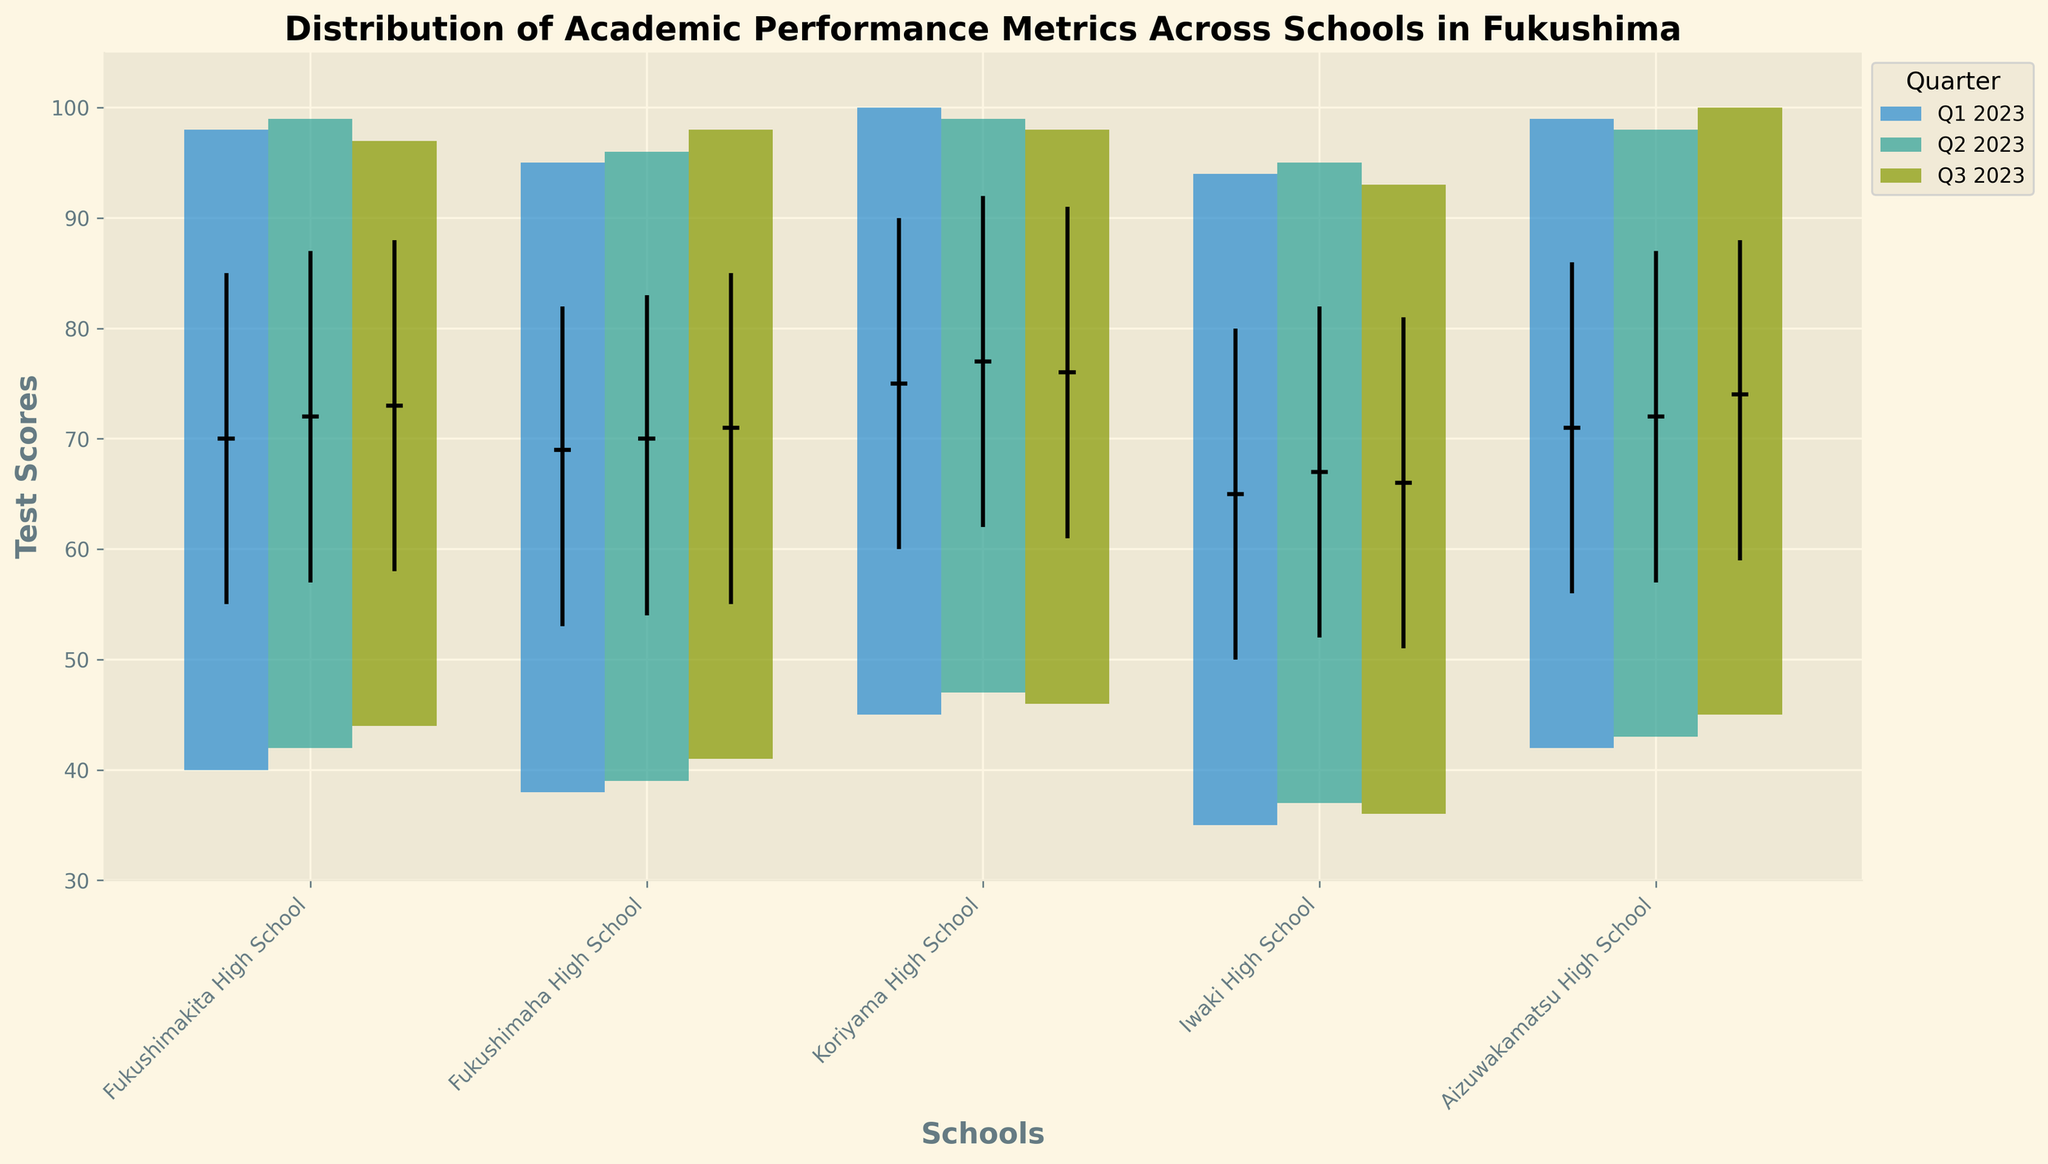What is the maximum test score in Koriyama High School for Q1 2023? First, find the bar corresponding to Koriyama High School for Q1 2023. The maximum test score in this quarter is marked by the top of the bar. According to the y-axis and the figure's labels, the maximum score for this school in Q1 2023 is 100.
Answer: 100 Which school had the lowest median score in Q1 2023, and what was that score? To find this, observe the black horizontal median lines for Q1 2023. The school with the lowest such line represents the lowest median score. For Q1 2023, Iwaki High School has the lowest median score at 65.
Answer: Iwaki High School, 65 How did Aizuwakamatsu High School's maximum score change from Q1 2023 to Q3 2023? Compare the topmost points of the bars for Aizuwakamatsu High School in Q1 and Q3 2023 to see the change. The score increased from 99 in Q1 2023 to 100 in Q3 2023, showing an increase of 1.
Answer: 1 point increase Which school has the highest range of test scores for Q2 2023, and what is that range? The range of test scores is the difference between the maximum score and the minimum score. For Q2 2023, find the school with the tallest bar. Koriyama High School has the highest range, calculated as 99 - 47 = 52.
Answer: Koriyama High School, 52 Across all schools and quarters, which school consistently shows the highest median scores? Look at the black horizontal median lines across all three quarters for each school. Koriyama High School consistently has high median scores, with median scores always above 75, making it the school with consistently highest median scores.
Answer: Koriyama High School Which school showed the most improvement in median score from Q1 2023 to Q3 2023? To determine the most improvement, compare the black median lines' height difference between Q1 2023 and Q3 2023 for each school. Aizuwakamatsu High School increased from 71 to 74, an improvement of 3 points, which is higher than any other school's change.
Answer: Aizuwakamatsu High School What is the interquartile range (IQR) for Fukushimakita High School in Q3 2023? The IQR is the difference between the 3rd quartile and the 1st quartile. For Fukushimakita High School in Q3 2023, the 3rd quartile score is 88, and the 1st quartile score is 58. Therefore, the IQR is 88 - 58 = 30.
Answer: 30 Comparing Q1 2023, which school had a greater 3rd quartile score: Fukushimaha High School or Iwaki High School? Look at the black vertical lines at the top of the boxes representing the 3rd quartile scores for both schools in Q1 2023. Fukushimaha High School's 3rd quartile score is 82, while Iwaki High School's is 80. Therefore, Fukushimaha High School has a greater 3rd quartile score.
Answer: Fukushimaha High School Is there any quarter where the minimum score for all schools is above 40? Examine the bottom ends of the bars for each school in each quarter. In Q2 2023 and Q3 2023, all schools have minimum scores above 40.
Answer: Yes, in Q2 2023 and Q3 2023 Which quarter saw the highest increase in mean scores for Fukushimakita High School compared to the previous quarter? Calculate the mean score for each quarter: (Min + 1st Q + Median + 3rd Q + Max) / 5 for each quarter.
Q1 Mean = (40 + 55 + 70 + 85 + 98) / 5 = 69.6
Q2 Mean = (42 + 57 + 72 + 87 + 99) / 5 = 71.4
Q3 Mean = (44 + 58 + 73 + 88 + 97) / 5 = 72 Overall, the mean went from 69.6 to 71.4 (1.8 points) in Q2, and 71.4 to 72 (0.6 points) in Q3. The highest increase was in Q2.
Answer: Q2 2023 